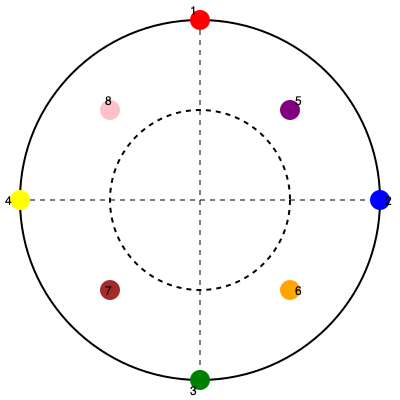In the given diagram of an 8-hand céilí formation, what is the geometric relationship between dancers 1, 2, 3, and 4, and how does this arrangement contribute to the symmetry and balance of the entire formation? Additionally, calculate the angle between any two adjacent dancers on the outer circle, assuming they are evenly spaced. 1. Geometric relationship of dancers 1, 2, 3, and 4:
   - These dancers form a perfect square inscribed within the larger circle.
   - They are positioned at the cardinal points (North, East, South, West) of the formation.
   - The lines connecting opposite dancers (1-3 and 2-4) are diameters of the circle.

2. Contribution to symmetry and balance:
   - The square arrangement creates a stable foundation for the formation.
   - It divides the circle into four equal quadrants, ensuring balance.
   - This layout allows for symmetrical movements and patterns in the dance.

3. Dancers 5, 6, 7, and 8:
   - They form a smaller square rotated 45° relative to the larger square.
   - This creates an octagon when considering all eight dancers.

4. Overall symmetry:
   - The formation has rotational symmetry of order 4 (90° rotations).
   - It also has four lines of reflectional symmetry.

5. Angle calculation:
   - In a circle, there are 360°.
   - With 8 evenly spaced dancers, the angle between adjacent dancers is:
     $$ \text{Angle} = \frac{360°}{8} = 45° $$

This formation allows for various symmetrical dance patterns and smooth transitions between different configurations, which is crucial in céilí dancing.
Answer: Dancers 1, 2, 3, and 4 form a square inscribed in the circle, creating four equal quadrants. The angle between adjacent dancers is 45°. 